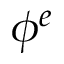<formula> <loc_0><loc_0><loc_500><loc_500>\phi ^ { e }</formula> 